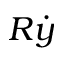<formula> <loc_0><loc_0><loc_500><loc_500>R \dot { y }</formula> 